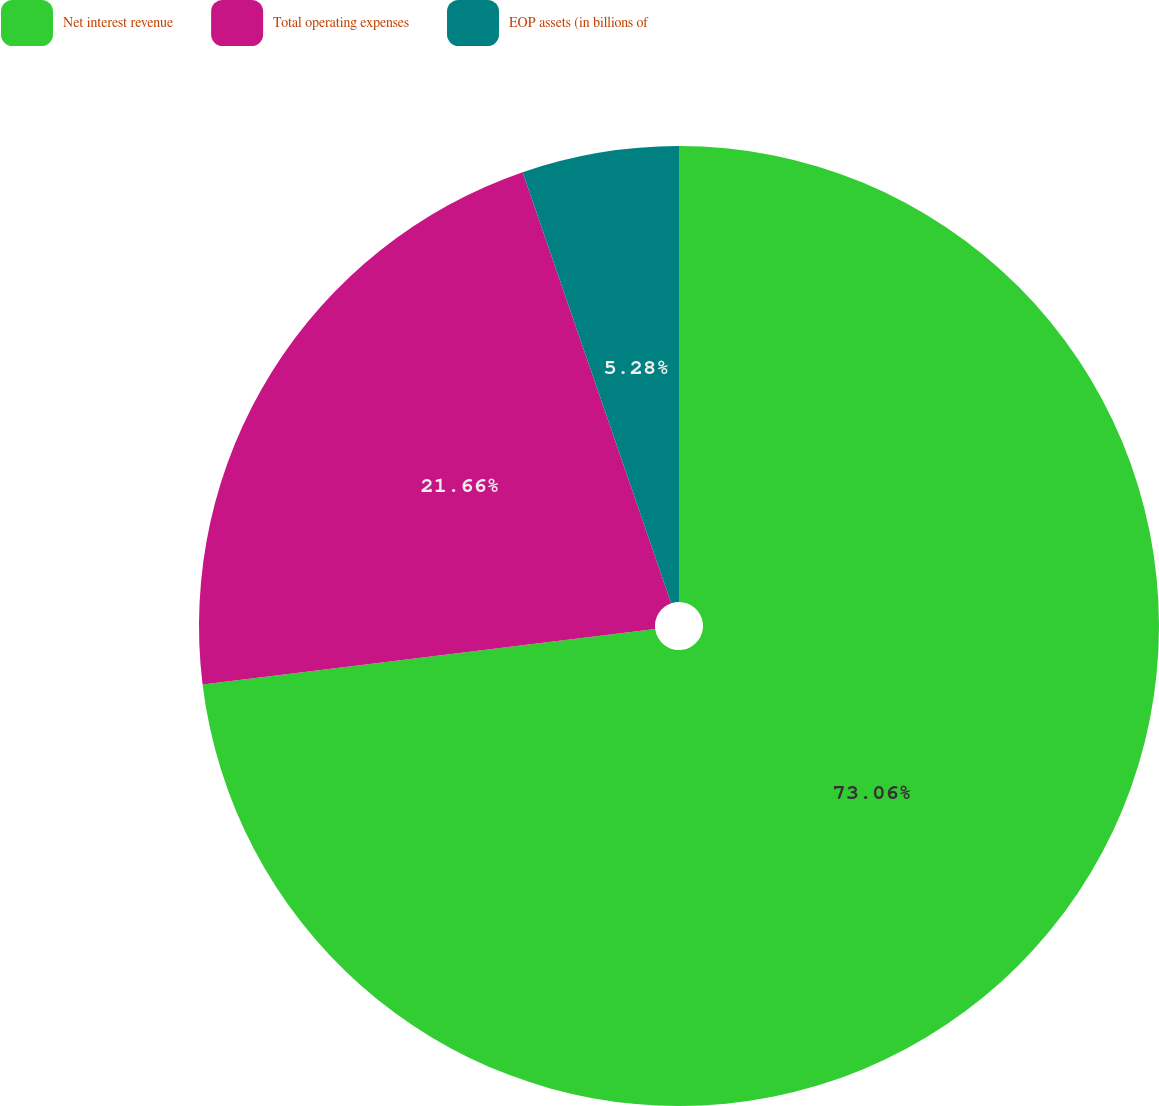<chart> <loc_0><loc_0><loc_500><loc_500><pie_chart><fcel>Net interest revenue<fcel>Total operating expenses<fcel>EOP assets (in billions of<nl><fcel>73.05%<fcel>21.66%<fcel>5.28%<nl></chart> 